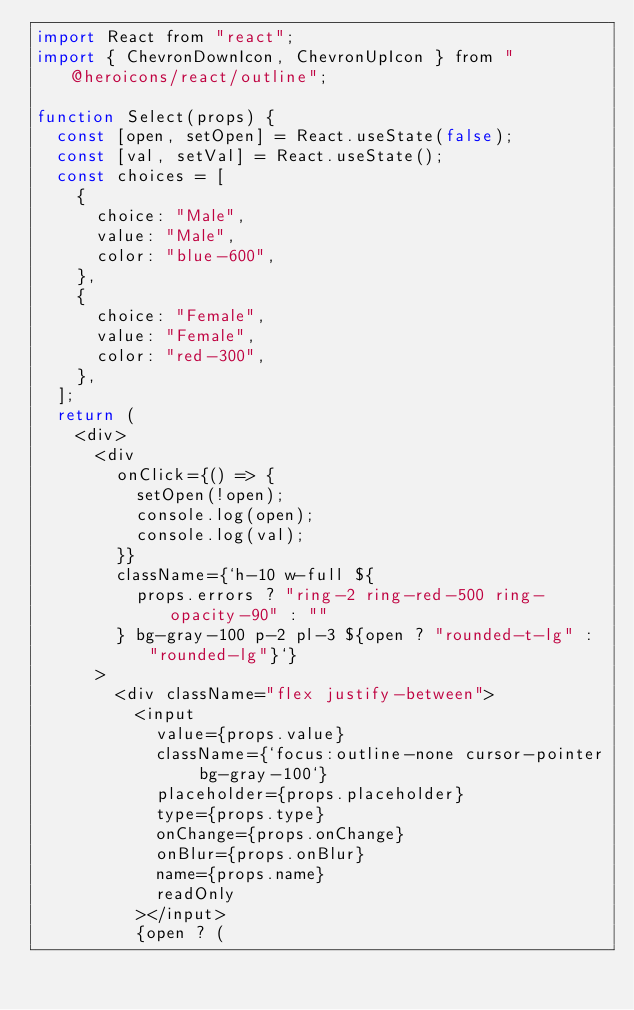<code> <loc_0><loc_0><loc_500><loc_500><_JavaScript_>import React from "react";
import { ChevronDownIcon, ChevronUpIcon } from "@heroicons/react/outline";

function Select(props) {
  const [open, setOpen] = React.useState(false);
  const [val, setVal] = React.useState();
  const choices = [
    {
      choice: "Male",
      value: "Male",
      color: "blue-600",
    },
    {
      choice: "Female",
      value: "Female",
      color: "red-300",
    },
  ];
  return (
    <div>
      <div
        onClick={() => {
          setOpen(!open);
          console.log(open);
          console.log(val);
        }}
        className={`h-10 w-full ${
          props.errors ? "ring-2 ring-red-500 ring-opacity-90" : ""
        } bg-gray-100 p-2 pl-3 ${open ? "rounded-t-lg" : "rounded-lg"}`}
      >
        <div className="flex justify-between">
          <input
            value={props.value}
            className={`focus:outline-none cursor-pointer bg-gray-100`}
            placeholder={props.placeholder}
            type={props.type}
            onChange={props.onChange}
            onBlur={props.onBlur}
            name={props.name}
            readOnly
          ></input>
          {open ? (</code> 